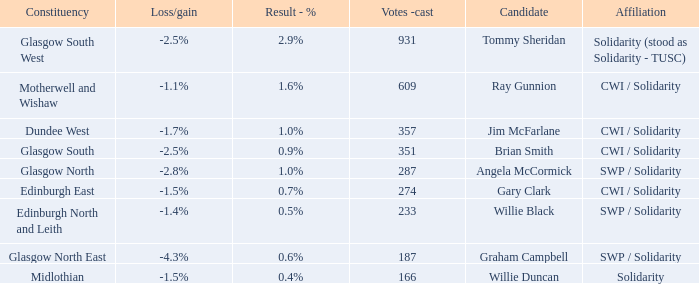How many votes were cast when the constituency was midlothian? 166.0. 